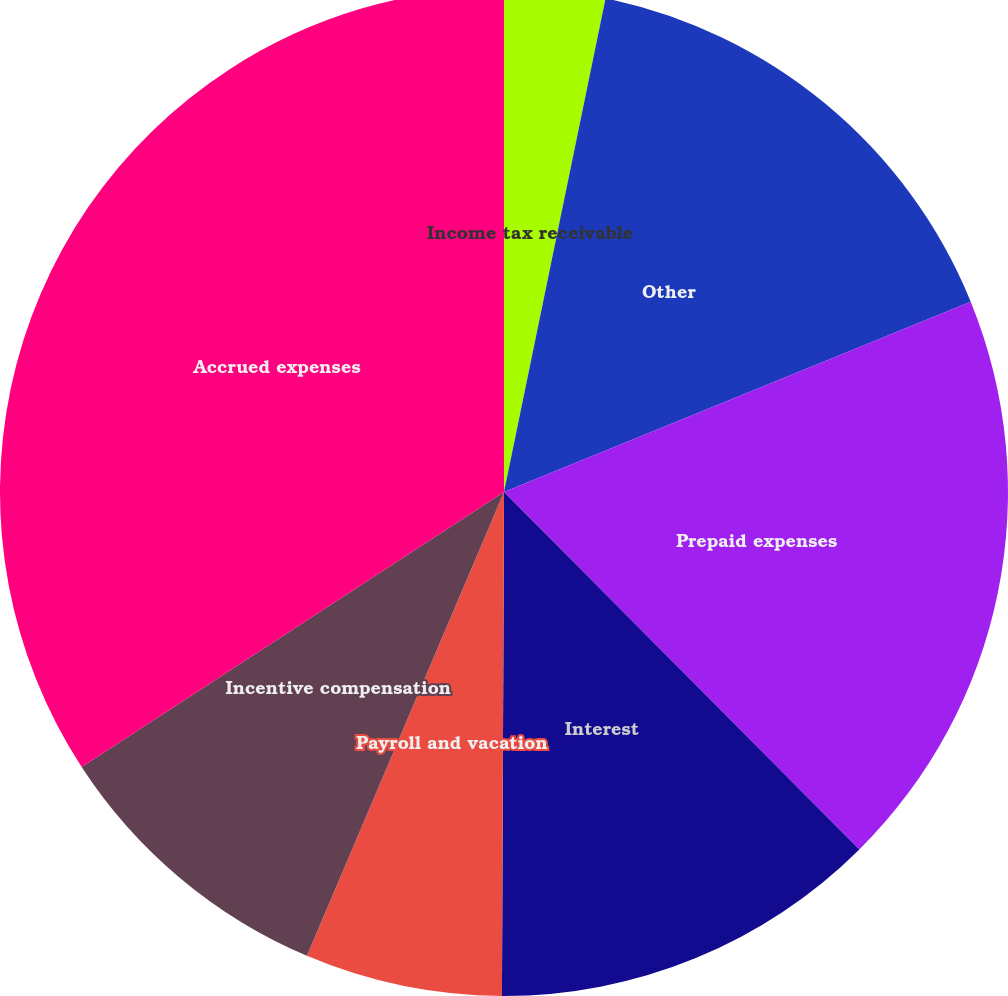<chart> <loc_0><loc_0><loc_500><loc_500><pie_chart><fcel>Income tax receivable<fcel>Other<fcel>Prepaid expenses<fcel>Interest<fcel>Payroll and vacation<fcel>Incentive compensation<fcel>Accrued expenses<nl><fcel>3.23%<fcel>15.61%<fcel>18.71%<fcel>12.52%<fcel>6.33%<fcel>9.42%<fcel>34.19%<nl></chart> 